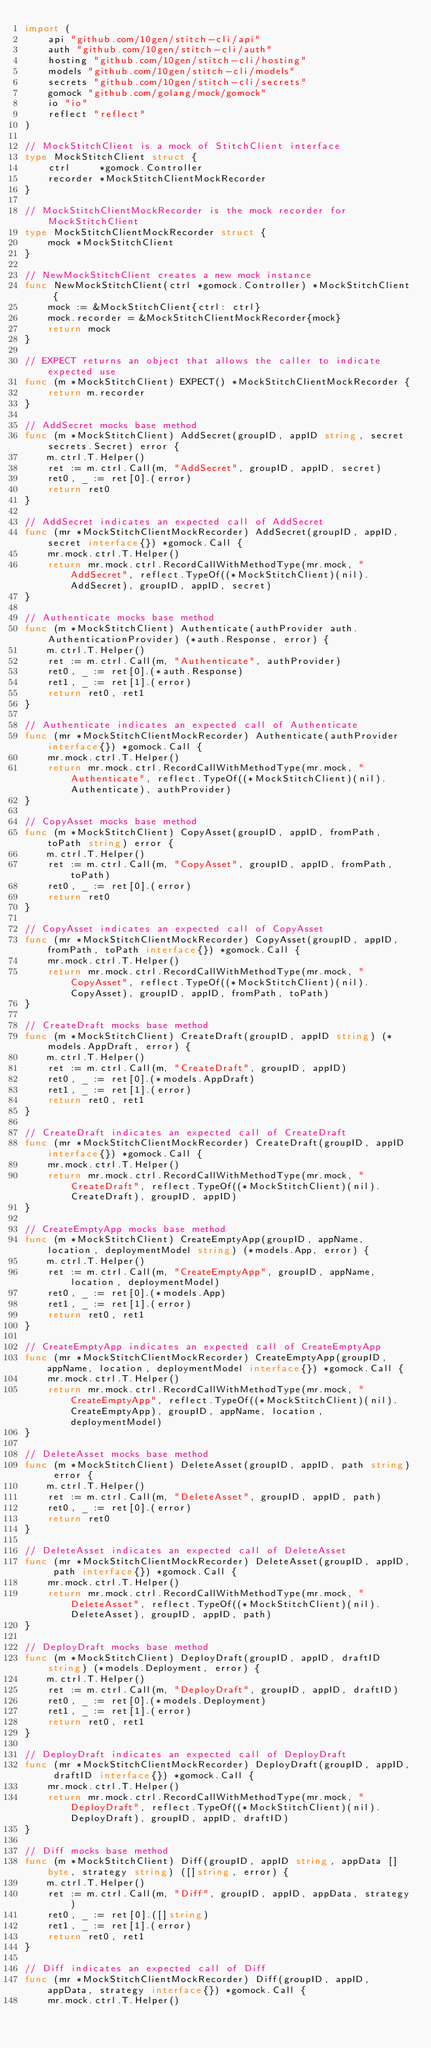<code> <loc_0><loc_0><loc_500><loc_500><_Go_>import (
	api "github.com/10gen/stitch-cli/api"
	auth "github.com/10gen/stitch-cli/auth"
	hosting "github.com/10gen/stitch-cli/hosting"
	models "github.com/10gen/stitch-cli/models"
	secrets "github.com/10gen/stitch-cli/secrets"
	gomock "github.com/golang/mock/gomock"
	io "io"
	reflect "reflect"
)

// MockStitchClient is a mock of StitchClient interface
type MockStitchClient struct {
	ctrl     *gomock.Controller
	recorder *MockStitchClientMockRecorder
}

// MockStitchClientMockRecorder is the mock recorder for MockStitchClient
type MockStitchClientMockRecorder struct {
	mock *MockStitchClient
}

// NewMockStitchClient creates a new mock instance
func NewMockStitchClient(ctrl *gomock.Controller) *MockStitchClient {
	mock := &MockStitchClient{ctrl: ctrl}
	mock.recorder = &MockStitchClientMockRecorder{mock}
	return mock
}

// EXPECT returns an object that allows the caller to indicate expected use
func (m *MockStitchClient) EXPECT() *MockStitchClientMockRecorder {
	return m.recorder
}

// AddSecret mocks base method
func (m *MockStitchClient) AddSecret(groupID, appID string, secret secrets.Secret) error {
	m.ctrl.T.Helper()
	ret := m.ctrl.Call(m, "AddSecret", groupID, appID, secret)
	ret0, _ := ret[0].(error)
	return ret0
}

// AddSecret indicates an expected call of AddSecret
func (mr *MockStitchClientMockRecorder) AddSecret(groupID, appID, secret interface{}) *gomock.Call {
	mr.mock.ctrl.T.Helper()
	return mr.mock.ctrl.RecordCallWithMethodType(mr.mock, "AddSecret", reflect.TypeOf((*MockStitchClient)(nil).AddSecret), groupID, appID, secret)
}

// Authenticate mocks base method
func (m *MockStitchClient) Authenticate(authProvider auth.AuthenticationProvider) (*auth.Response, error) {
	m.ctrl.T.Helper()
	ret := m.ctrl.Call(m, "Authenticate", authProvider)
	ret0, _ := ret[0].(*auth.Response)
	ret1, _ := ret[1].(error)
	return ret0, ret1
}

// Authenticate indicates an expected call of Authenticate
func (mr *MockStitchClientMockRecorder) Authenticate(authProvider interface{}) *gomock.Call {
	mr.mock.ctrl.T.Helper()
	return mr.mock.ctrl.RecordCallWithMethodType(mr.mock, "Authenticate", reflect.TypeOf((*MockStitchClient)(nil).Authenticate), authProvider)
}

// CopyAsset mocks base method
func (m *MockStitchClient) CopyAsset(groupID, appID, fromPath, toPath string) error {
	m.ctrl.T.Helper()
	ret := m.ctrl.Call(m, "CopyAsset", groupID, appID, fromPath, toPath)
	ret0, _ := ret[0].(error)
	return ret0
}

// CopyAsset indicates an expected call of CopyAsset
func (mr *MockStitchClientMockRecorder) CopyAsset(groupID, appID, fromPath, toPath interface{}) *gomock.Call {
	mr.mock.ctrl.T.Helper()
	return mr.mock.ctrl.RecordCallWithMethodType(mr.mock, "CopyAsset", reflect.TypeOf((*MockStitchClient)(nil).CopyAsset), groupID, appID, fromPath, toPath)
}

// CreateDraft mocks base method
func (m *MockStitchClient) CreateDraft(groupID, appID string) (*models.AppDraft, error) {
	m.ctrl.T.Helper()
	ret := m.ctrl.Call(m, "CreateDraft", groupID, appID)
	ret0, _ := ret[0].(*models.AppDraft)
	ret1, _ := ret[1].(error)
	return ret0, ret1
}

// CreateDraft indicates an expected call of CreateDraft
func (mr *MockStitchClientMockRecorder) CreateDraft(groupID, appID interface{}) *gomock.Call {
	mr.mock.ctrl.T.Helper()
	return mr.mock.ctrl.RecordCallWithMethodType(mr.mock, "CreateDraft", reflect.TypeOf((*MockStitchClient)(nil).CreateDraft), groupID, appID)
}

// CreateEmptyApp mocks base method
func (m *MockStitchClient) CreateEmptyApp(groupID, appName, location, deploymentModel string) (*models.App, error) {
	m.ctrl.T.Helper()
	ret := m.ctrl.Call(m, "CreateEmptyApp", groupID, appName, location, deploymentModel)
	ret0, _ := ret[0].(*models.App)
	ret1, _ := ret[1].(error)
	return ret0, ret1
}

// CreateEmptyApp indicates an expected call of CreateEmptyApp
func (mr *MockStitchClientMockRecorder) CreateEmptyApp(groupID, appName, location, deploymentModel interface{}) *gomock.Call {
	mr.mock.ctrl.T.Helper()
	return mr.mock.ctrl.RecordCallWithMethodType(mr.mock, "CreateEmptyApp", reflect.TypeOf((*MockStitchClient)(nil).CreateEmptyApp), groupID, appName, location, deploymentModel)
}

// DeleteAsset mocks base method
func (m *MockStitchClient) DeleteAsset(groupID, appID, path string) error {
	m.ctrl.T.Helper()
	ret := m.ctrl.Call(m, "DeleteAsset", groupID, appID, path)
	ret0, _ := ret[0].(error)
	return ret0
}

// DeleteAsset indicates an expected call of DeleteAsset
func (mr *MockStitchClientMockRecorder) DeleteAsset(groupID, appID, path interface{}) *gomock.Call {
	mr.mock.ctrl.T.Helper()
	return mr.mock.ctrl.RecordCallWithMethodType(mr.mock, "DeleteAsset", reflect.TypeOf((*MockStitchClient)(nil).DeleteAsset), groupID, appID, path)
}

// DeployDraft mocks base method
func (m *MockStitchClient) DeployDraft(groupID, appID, draftID string) (*models.Deployment, error) {
	m.ctrl.T.Helper()
	ret := m.ctrl.Call(m, "DeployDraft", groupID, appID, draftID)
	ret0, _ := ret[0].(*models.Deployment)
	ret1, _ := ret[1].(error)
	return ret0, ret1
}

// DeployDraft indicates an expected call of DeployDraft
func (mr *MockStitchClientMockRecorder) DeployDraft(groupID, appID, draftID interface{}) *gomock.Call {
	mr.mock.ctrl.T.Helper()
	return mr.mock.ctrl.RecordCallWithMethodType(mr.mock, "DeployDraft", reflect.TypeOf((*MockStitchClient)(nil).DeployDraft), groupID, appID, draftID)
}

// Diff mocks base method
func (m *MockStitchClient) Diff(groupID, appID string, appData []byte, strategy string) ([]string, error) {
	m.ctrl.T.Helper()
	ret := m.ctrl.Call(m, "Diff", groupID, appID, appData, strategy)
	ret0, _ := ret[0].([]string)
	ret1, _ := ret[1].(error)
	return ret0, ret1
}

// Diff indicates an expected call of Diff
func (mr *MockStitchClientMockRecorder) Diff(groupID, appID, appData, strategy interface{}) *gomock.Call {
	mr.mock.ctrl.T.Helper()</code> 